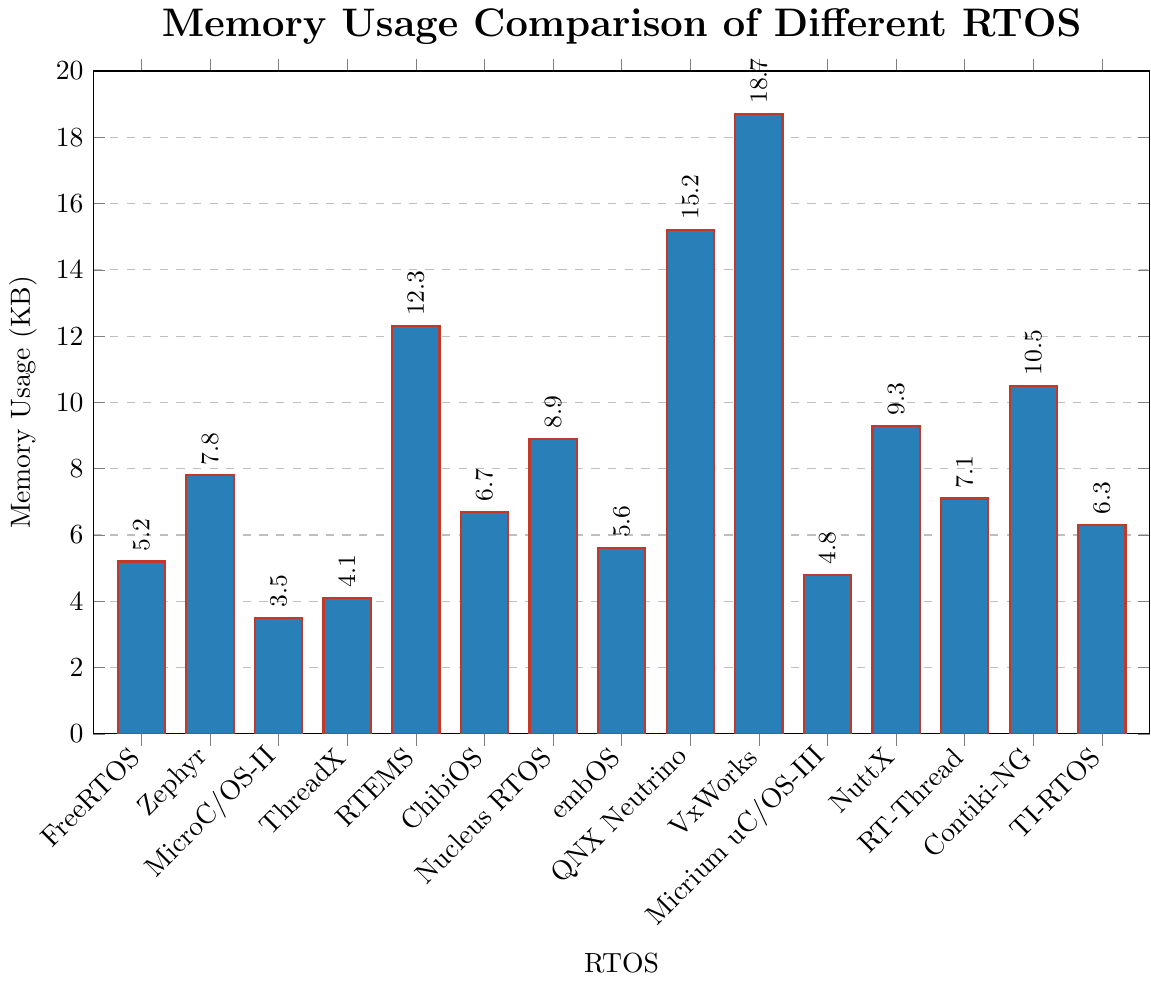Which RTOS has the highest memory usage? Looking at the height of the bars, we can see that VxWorks has the tallest bar, indicating it has the highest memory usage.
Answer: VxWorks Which RTOS has the second highest memory usage? By comparing the heights of the bars, QNX Neutrino has the second highest bar after VxWorks.
Answer: QNX Neutrino What is the difference in memory usage between the RTOS with the highest and lowest memory usage? VxWorks has the highest memory usage at 18.7 KB and MicroC/OS-II has the lowest at 3.5 KB. The difference is 18.7 - 3.5 = 15.2 KB.
Answer: 15.2 KB How many RTOSs have a memory usage of more than 10 KB? Looking at the bars, the RTOSs with more than 10 KB are RTEMS, QNX Neutrino, VxWorks, Contiki-NG, and NuttX. There are 5 RTOSs in this category.
Answer: 5 What is the average memory usage of all the RTOSs? Sum of all memory usages is 5.2 + 7.8 + 3.5 + 4.1 + 12.3 + 6.7 + 8.9 + 5.6 + 15.2 + 18.7 + 4.8 + 9.3 + 7.1 + 10.5 + 6.3 = 126.1. There are 15 RTOSs, so the average is 126.1 / 15 = 8.41 KB.
Answer: 8.41 KB How does the memory usage of Zephyr compare to that of FreeRTOS? Zephyr has a memory usage of 7.8 KB while FreeRTOS has 5.2 KB. Zephyr’s memory usage is higher by 2.6 KB.
Answer: Zephyr uses 2.6 KB more Which RTOS has the closest memory usage to the average memory usage of all RTOSs? The average memory usage is 8.41 KB. Nucleus RTOS with 8.9 KB is the closest to this average.
Answer: Nucleus RTOS List the RTOSs in ascending order of their memory usage. Starting from the smallest bar to the largest: MicroC/OS-II (3.5), ThreadX (4.1), Micrium uC/OS-III (4.8), FreeRTOS (5.2), embOS (5.6), TI-RTOS (6.3), ChibiOS (6.7), RT-Thread (7.1), Zephyr (7.8), Nucleus RTOS (8.9), NuttX (9.3), Contiki-NG (10.5), RTEMS (12.3), QNX Neutrino (15.2), VxWorks (18.7).
Answer: MicroC/OS-II, ThreadX, Micrium uC/OS-III, FreeRTOS, embOS, TI-RTOS, ChibiOS, RT-Thread, Zephyr, Nucleus RTOS, NuttX, Contiki-NG, RTEMS, QNX Neutrino, VxWorks Does any RTOS have a memory usage equal to the median memory usage? If so, which one? The median of the memory usage values (ordered list): 3.5, 4.1, 4.8, 5.2, 5.6, 6.3, 6.7, 7.1, 7.8, 8.9, 9.3, 10.5, 12.3, 15.2, 18.7. The median (8th value) is 7.1 KB, matching RT-Thread.
Answer: RT-Thread 